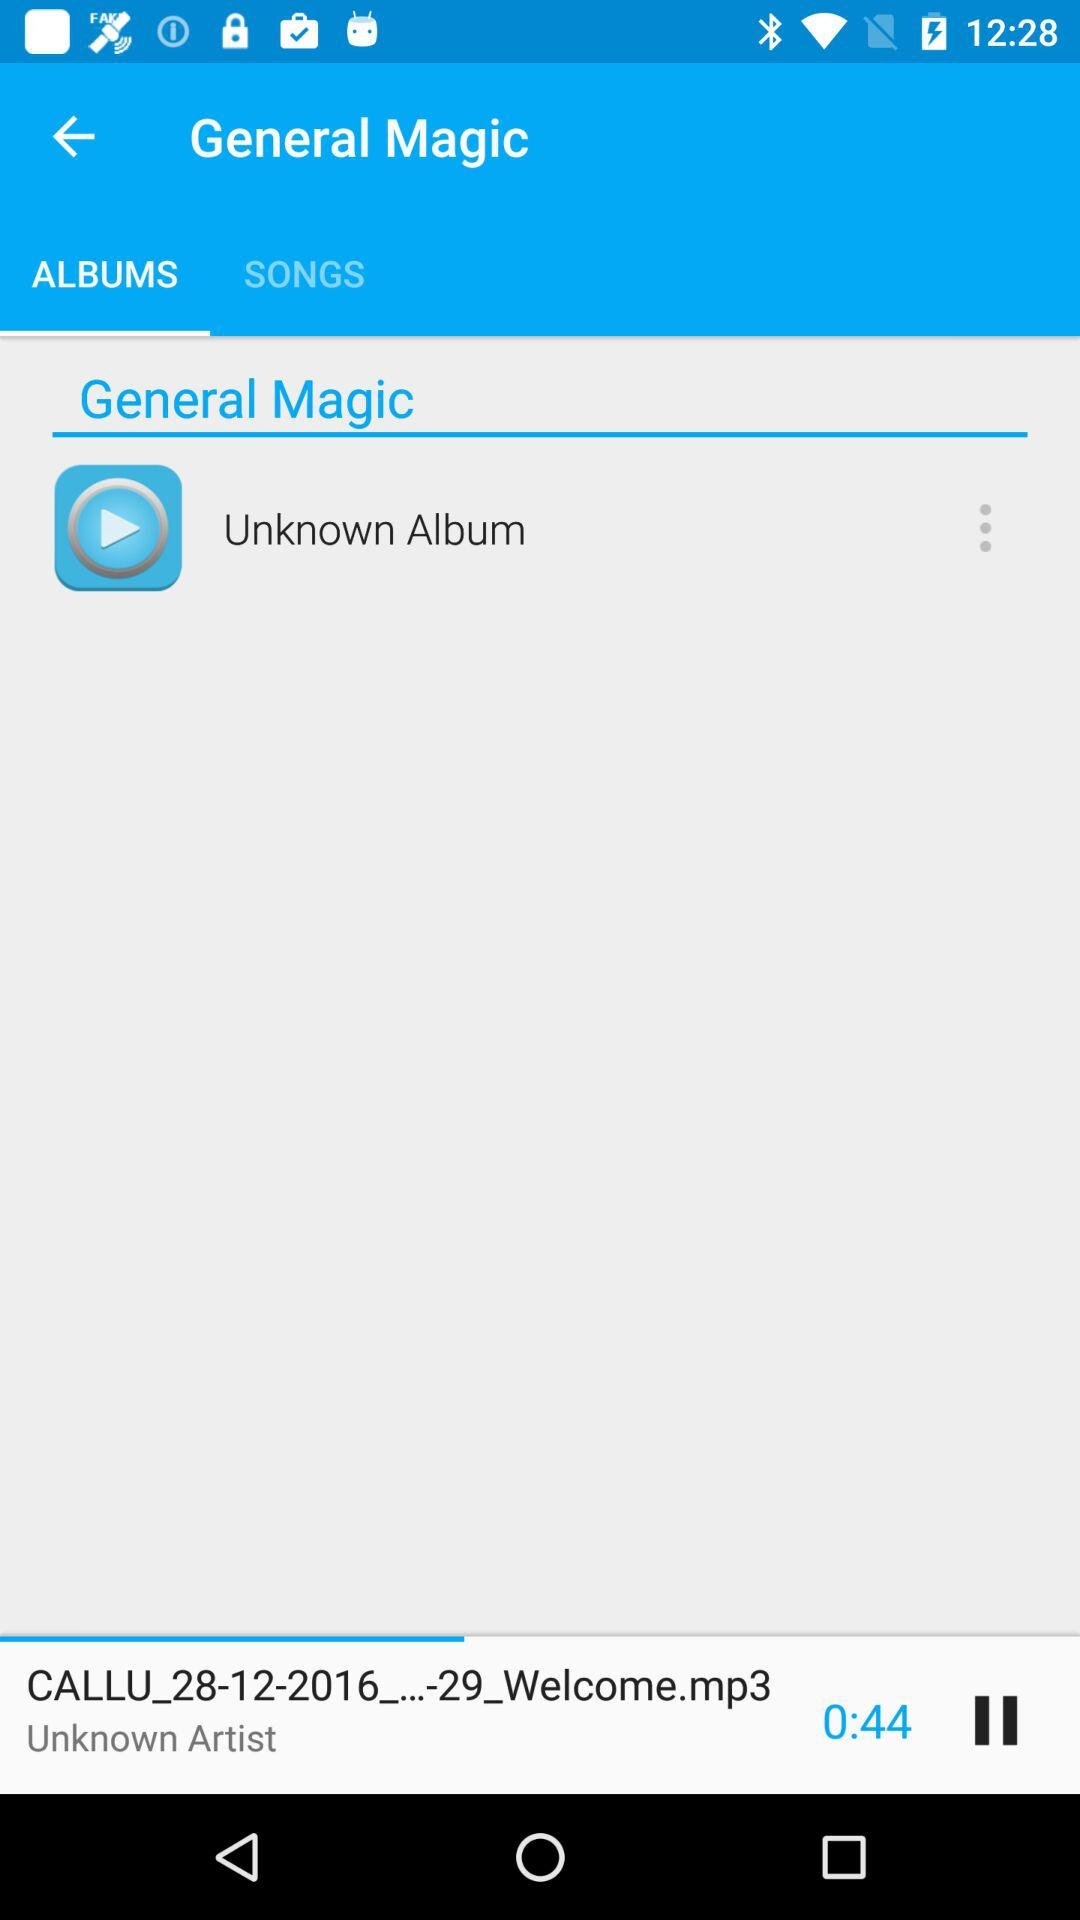How long is the song?
Answer the question using a single word or phrase. 0:44 